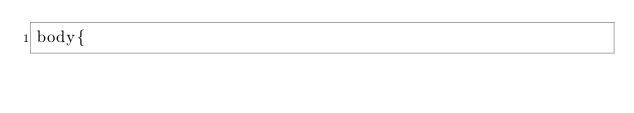<code> <loc_0><loc_0><loc_500><loc_500><_CSS_>body{</code> 